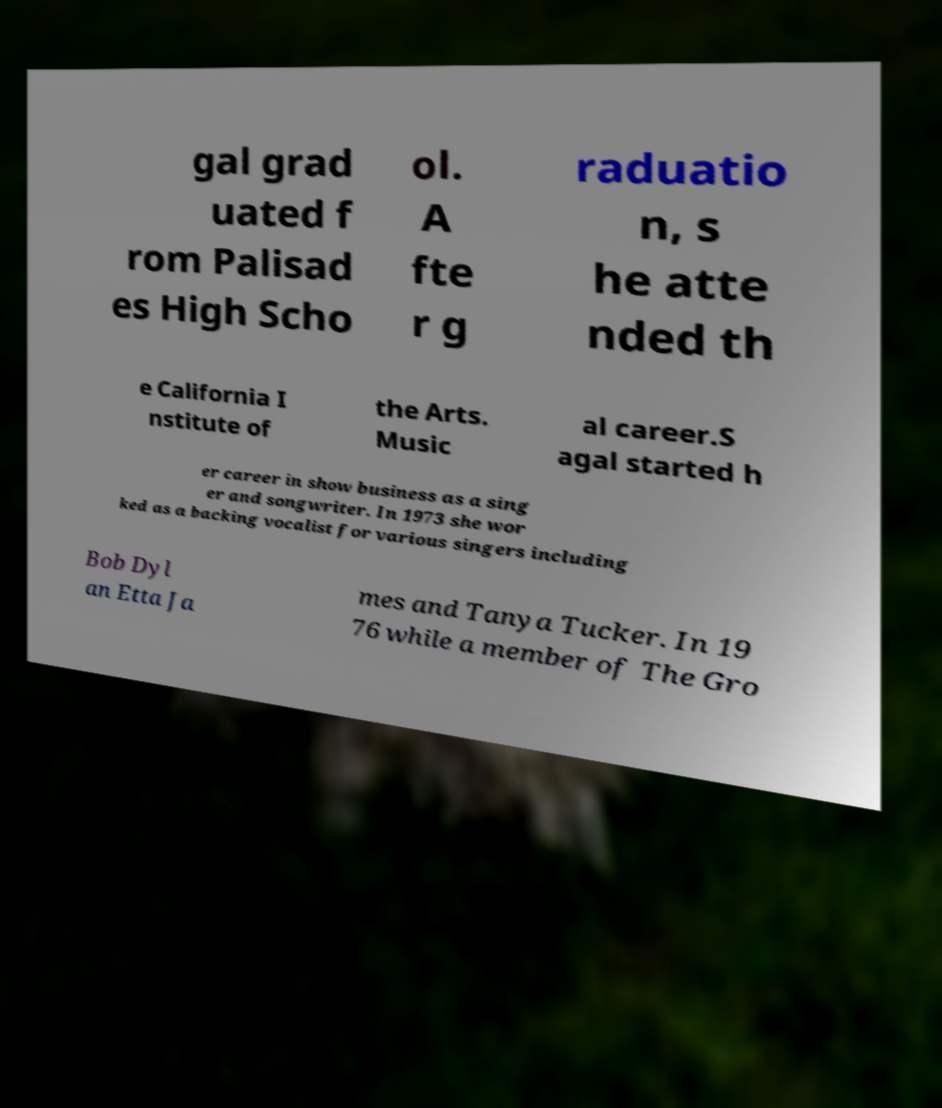I need the written content from this picture converted into text. Can you do that? gal grad uated f rom Palisad es High Scho ol. A fte r g raduatio n, s he atte nded th e California I nstitute of the Arts. Music al career.S agal started h er career in show business as a sing er and songwriter. In 1973 she wor ked as a backing vocalist for various singers including Bob Dyl an Etta Ja mes and Tanya Tucker. In 19 76 while a member of The Gro 